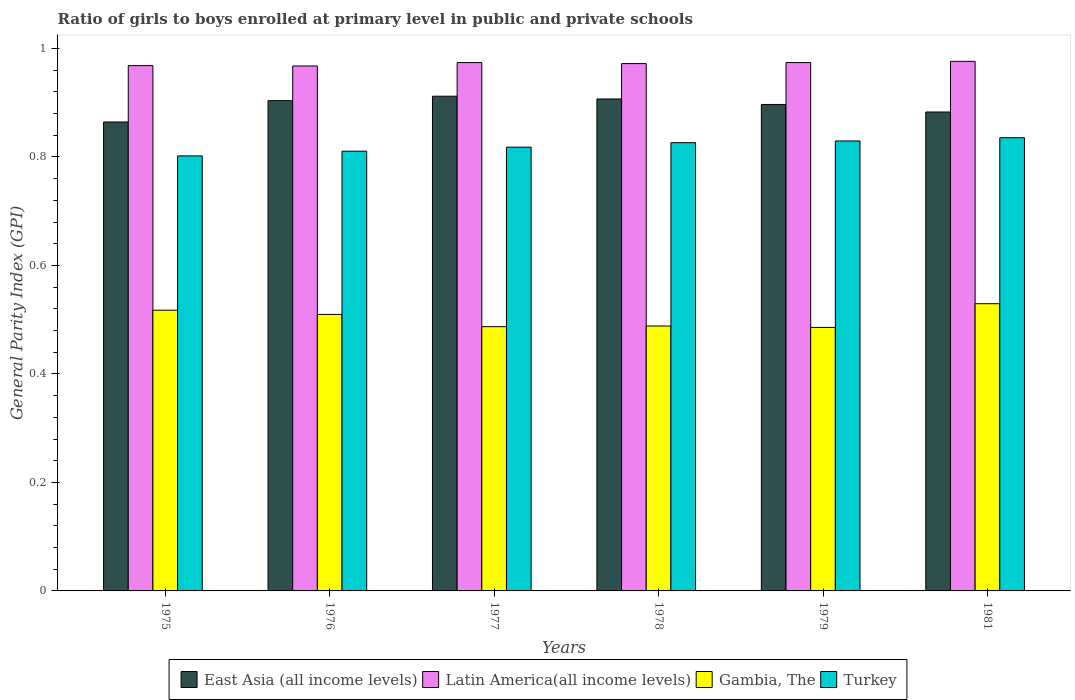Are the number of bars on each tick of the X-axis equal?
Provide a short and direct response. Yes. How many bars are there on the 1st tick from the left?
Keep it short and to the point. 4. How many bars are there on the 2nd tick from the right?
Your response must be concise. 4. What is the label of the 1st group of bars from the left?
Ensure brevity in your answer.  1975. What is the general parity index in Latin America(all income levels) in 1977?
Your answer should be compact. 0.97. Across all years, what is the maximum general parity index in Gambia, The?
Offer a terse response. 0.53. Across all years, what is the minimum general parity index in Turkey?
Keep it short and to the point. 0.8. In which year was the general parity index in Gambia, The maximum?
Offer a terse response. 1981. In which year was the general parity index in East Asia (all income levels) minimum?
Your response must be concise. 1975. What is the total general parity index in Latin America(all income levels) in the graph?
Make the answer very short. 5.83. What is the difference between the general parity index in Turkey in 1975 and that in 1978?
Keep it short and to the point. -0.02. What is the difference between the general parity index in Latin America(all income levels) in 1978 and the general parity index in Turkey in 1979?
Your response must be concise. 0.14. What is the average general parity index in Gambia, The per year?
Offer a very short reply. 0.5. In the year 1979, what is the difference between the general parity index in Turkey and general parity index in Gambia, The?
Offer a terse response. 0.34. What is the ratio of the general parity index in Gambia, The in 1978 to that in 1981?
Provide a short and direct response. 0.92. What is the difference between the highest and the second highest general parity index in Gambia, The?
Provide a succinct answer. 0.01. What is the difference between the highest and the lowest general parity index in Turkey?
Your answer should be compact. 0.03. What does the 2nd bar from the left in 1981 represents?
Give a very brief answer. Latin America(all income levels). What does the 2nd bar from the right in 1978 represents?
Keep it short and to the point. Gambia, The. How many bars are there?
Provide a succinct answer. 24. How many years are there in the graph?
Provide a short and direct response. 6. Does the graph contain grids?
Your answer should be very brief. No. How are the legend labels stacked?
Offer a very short reply. Horizontal. What is the title of the graph?
Make the answer very short. Ratio of girls to boys enrolled at primary level in public and private schools. What is the label or title of the X-axis?
Provide a short and direct response. Years. What is the label or title of the Y-axis?
Your answer should be compact. General Parity Index (GPI). What is the General Parity Index (GPI) of East Asia (all income levels) in 1975?
Make the answer very short. 0.86. What is the General Parity Index (GPI) of Latin America(all income levels) in 1975?
Your answer should be compact. 0.97. What is the General Parity Index (GPI) in Gambia, The in 1975?
Provide a succinct answer. 0.52. What is the General Parity Index (GPI) in Turkey in 1975?
Provide a succinct answer. 0.8. What is the General Parity Index (GPI) of East Asia (all income levels) in 1976?
Your answer should be compact. 0.9. What is the General Parity Index (GPI) of Latin America(all income levels) in 1976?
Provide a short and direct response. 0.97. What is the General Parity Index (GPI) in Gambia, The in 1976?
Your answer should be very brief. 0.51. What is the General Parity Index (GPI) in Turkey in 1976?
Your answer should be very brief. 0.81. What is the General Parity Index (GPI) in East Asia (all income levels) in 1977?
Your answer should be compact. 0.91. What is the General Parity Index (GPI) in Latin America(all income levels) in 1977?
Provide a succinct answer. 0.97. What is the General Parity Index (GPI) of Gambia, The in 1977?
Provide a succinct answer. 0.49. What is the General Parity Index (GPI) of Turkey in 1977?
Give a very brief answer. 0.82. What is the General Parity Index (GPI) of East Asia (all income levels) in 1978?
Provide a succinct answer. 0.91. What is the General Parity Index (GPI) of Latin America(all income levels) in 1978?
Your answer should be very brief. 0.97. What is the General Parity Index (GPI) in Gambia, The in 1978?
Offer a terse response. 0.49. What is the General Parity Index (GPI) of Turkey in 1978?
Offer a very short reply. 0.83. What is the General Parity Index (GPI) in East Asia (all income levels) in 1979?
Offer a very short reply. 0.9. What is the General Parity Index (GPI) of Latin America(all income levels) in 1979?
Your answer should be compact. 0.97. What is the General Parity Index (GPI) of Gambia, The in 1979?
Your answer should be compact. 0.49. What is the General Parity Index (GPI) in Turkey in 1979?
Make the answer very short. 0.83. What is the General Parity Index (GPI) in East Asia (all income levels) in 1981?
Keep it short and to the point. 0.88. What is the General Parity Index (GPI) in Latin America(all income levels) in 1981?
Your response must be concise. 0.98. What is the General Parity Index (GPI) in Gambia, The in 1981?
Give a very brief answer. 0.53. What is the General Parity Index (GPI) of Turkey in 1981?
Provide a succinct answer. 0.84. Across all years, what is the maximum General Parity Index (GPI) in East Asia (all income levels)?
Give a very brief answer. 0.91. Across all years, what is the maximum General Parity Index (GPI) of Latin America(all income levels)?
Your response must be concise. 0.98. Across all years, what is the maximum General Parity Index (GPI) in Gambia, The?
Your answer should be compact. 0.53. Across all years, what is the maximum General Parity Index (GPI) in Turkey?
Give a very brief answer. 0.84. Across all years, what is the minimum General Parity Index (GPI) of East Asia (all income levels)?
Ensure brevity in your answer.  0.86. Across all years, what is the minimum General Parity Index (GPI) of Latin America(all income levels)?
Provide a succinct answer. 0.97. Across all years, what is the minimum General Parity Index (GPI) in Gambia, The?
Ensure brevity in your answer.  0.49. Across all years, what is the minimum General Parity Index (GPI) of Turkey?
Give a very brief answer. 0.8. What is the total General Parity Index (GPI) in East Asia (all income levels) in the graph?
Ensure brevity in your answer.  5.37. What is the total General Parity Index (GPI) in Latin America(all income levels) in the graph?
Your answer should be compact. 5.83. What is the total General Parity Index (GPI) in Gambia, The in the graph?
Offer a very short reply. 3.02. What is the total General Parity Index (GPI) of Turkey in the graph?
Provide a succinct answer. 4.92. What is the difference between the General Parity Index (GPI) in East Asia (all income levels) in 1975 and that in 1976?
Give a very brief answer. -0.04. What is the difference between the General Parity Index (GPI) of Latin America(all income levels) in 1975 and that in 1976?
Give a very brief answer. 0. What is the difference between the General Parity Index (GPI) of Gambia, The in 1975 and that in 1976?
Ensure brevity in your answer.  0.01. What is the difference between the General Parity Index (GPI) of Turkey in 1975 and that in 1976?
Offer a terse response. -0.01. What is the difference between the General Parity Index (GPI) in East Asia (all income levels) in 1975 and that in 1977?
Make the answer very short. -0.05. What is the difference between the General Parity Index (GPI) of Latin America(all income levels) in 1975 and that in 1977?
Offer a very short reply. -0.01. What is the difference between the General Parity Index (GPI) in Gambia, The in 1975 and that in 1977?
Ensure brevity in your answer.  0.03. What is the difference between the General Parity Index (GPI) of Turkey in 1975 and that in 1977?
Your answer should be very brief. -0.02. What is the difference between the General Parity Index (GPI) of East Asia (all income levels) in 1975 and that in 1978?
Your response must be concise. -0.04. What is the difference between the General Parity Index (GPI) of Latin America(all income levels) in 1975 and that in 1978?
Make the answer very short. -0. What is the difference between the General Parity Index (GPI) in Gambia, The in 1975 and that in 1978?
Make the answer very short. 0.03. What is the difference between the General Parity Index (GPI) in Turkey in 1975 and that in 1978?
Make the answer very short. -0.02. What is the difference between the General Parity Index (GPI) in East Asia (all income levels) in 1975 and that in 1979?
Offer a terse response. -0.03. What is the difference between the General Parity Index (GPI) of Latin America(all income levels) in 1975 and that in 1979?
Give a very brief answer. -0.01. What is the difference between the General Parity Index (GPI) of Gambia, The in 1975 and that in 1979?
Give a very brief answer. 0.03. What is the difference between the General Parity Index (GPI) in Turkey in 1975 and that in 1979?
Your answer should be very brief. -0.03. What is the difference between the General Parity Index (GPI) of East Asia (all income levels) in 1975 and that in 1981?
Provide a short and direct response. -0.02. What is the difference between the General Parity Index (GPI) in Latin America(all income levels) in 1975 and that in 1981?
Ensure brevity in your answer.  -0.01. What is the difference between the General Parity Index (GPI) of Gambia, The in 1975 and that in 1981?
Your response must be concise. -0.01. What is the difference between the General Parity Index (GPI) in Turkey in 1975 and that in 1981?
Offer a terse response. -0.03. What is the difference between the General Parity Index (GPI) in East Asia (all income levels) in 1976 and that in 1977?
Offer a terse response. -0.01. What is the difference between the General Parity Index (GPI) in Latin America(all income levels) in 1976 and that in 1977?
Provide a short and direct response. -0.01. What is the difference between the General Parity Index (GPI) of Gambia, The in 1976 and that in 1977?
Give a very brief answer. 0.02. What is the difference between the General Parity Index (GPI) of Turkey in 1976 and that in 1977?
Offer a very short reply. -0.01. What is the difference between the General Parity Index (GPI) of East Asia (all income levels) in 1976 and that in 1978?
Your response must be concise. -0. What is the difference between the General Parity Index (GPI) of Latin America(all income levels) in 1976 and that in 1978?
Provide a succinct answer. -0. What is the difference between the General Parity Index (GPI) of Gambia, The in 1976 and that in 1978?
Provide a succinct answer. 0.02. What is the difference between the General Parity Index (GPI) in Turkey in 1976 and that in 1978?
Your answer should be compact. -0.02. What is the difference between the General Parity Index (GPI) in East Asia (all income levels) in 1976 and that in 1979?
Make the answer very short. 0.01. What is the difference between the General Parity Index (GPI) in Latin America(all income levels) in 1976 and that in 1979?
Your answer should be very brief. -0.01. What is the difference between the General Parity Index (GPI) in Gambia, The in 1976 and that in 1979?
Provide a short and direct response. 0.02. What is the difference between the General Parity Index (GPI) of Turkey in 1976 and that in 1979?
Keep it short and to the point. -0.02. What is the difference between the General Parity Index (GPI) of East Asia (all income levels) in 1976 and that in 1981?
Provide a succinct answer. 0.02. What is the difference between the General Parity Index (GPI) in Latin America(all income levels) in 1976 and that in 1981?
Your answer should be very brief. -0.01. What is the difference between the General Parity Index (GPI) in Gambia, The in 1976 and that in 1981?
Keep it short and to the point. -0.02. What is the difference between the General Parity Index (GPI) of Turkey in 1976 and that in 1981?
Ensure brevity in your answer.  -0.02. What is the difference between the General Parity Index (GPI) in East Asia (all income levels) in 1977 and that in 1978?
Provide a succinct answer. 0.01. What is the difference between the General Parity Index (GPI) in Latin America(all income levels) in 1977 and that in 1978?
Your response must be concise. 0. What is the difference between the General Parity Index (GPI) of Gambia, The in 1977 and that in 1978?
Give a very brief answer. -0. What is the difference between the General Parity Index (GPI) of Turkey in 1977 and that in 1978?
Offer a terse response. -0.01. What is the difference between the General Parity Index (GPI) of East Asia (all income levels) in 1977 and that in 1979?
Ensure brevity in your answer.  0.02. What is the difference between the General Parity Index (GPI) in Latin America(all income levels) in 1977 and that in 1979?
Your answer should be compact. 0. What is the difference between the General Parity Index (GPI) of Gambia, The in 1977 and that in 1979?
Your answer should be compact. 0. What is the difference between the General Parity Index (GPI) in Turkey in 1977 and that in 1979?
Your answer should be compact. -0.01. What is the difference between the General Parity Index (GPI) in East Asia (all income levels) in 1977 and that in 1981?
Give a very brief answer. 0.03. What is the difference between the General Parity Index (GPI) in Latin America(all income levels) in 1977 and that in 1981?
Offer a terse response. -0. What is the difference between the General Parity Index (GPI) of Gambia, The in 1977 and that in 1981?
Offer a very short reply. -0.04. What is the difference between the General Parity Index (GPI) in Turkey in 1977 and that in 1981?
Your answer should be compact. -0.02. What is the difference between the General Parity Index (GPI) in East Asia (all income levels) in 1978 and that in 1979?
Provide a succinct answer. 0.01. What is the difference between the General Parity Index (GPI) in Latin America(all income levels) in 1978 and that in 1979?
Give a very brief answer. -0. What is the difference between the General Parity Index (GPI) in Gambia, The in 1978 and that in 1979?
Your answer should be very brief. 0. What is the difference between the General Parity Index (GPI) of Turkey in 1978 and that in 1979?
Your response must be concise. -0. What is the difference between the General Parity Index (GPI) of East Asia (all income levels) in 1978 and that in 1981?
Keep it short and to the point. 0.02. What is the difference between the General Parity Index (GPI) of Latin America(all income levels) in 1978 and that in 1981?
Your answer should be compact. -0. What is the difference between the General Parity Index (GPI) in Gambia, The in 1978 and that in 1981?
Provide a short and direct response. -0.04. What is the difference between the General Parity Index (GPI) of Turkey in 1978 and that in 1981?
Give a very brief answer. -0.01. What is the difference between the General Parity Index (GPI) in East Asia (all income levels) in 1979 and that in 1981?
Your answer should be compact. 0.01. What is the difference between the General Parity Index (GPI) of Latin America(all income levels) in 1979 and that in 1981?
Provide a short and direct response. -0. What is the difference between the General Parity Index (GPI) of Gambia, The in 1979 and that in 1981?
Offer a terse response. -0.04. What is the difference between the General Parity Index (GPI) in Turkey in 1979 and that in 1981?
Provide a succinct answer. -0.01. What is the difference between the General Parity Index (GPI) of East Asia (all income levels) in 1975 and the General Parity Index (GPI) of Latin America(all income levels) in 1976?
Provide a short and direct response. -0.1. What is the difference between the General Parity Index (GPI) of East Asia (all income levels) in 1975 and the General Parity Index (GPI) of Gambia, The in 1976?
Ensure brevity in your answer.  0.35. What is the difference between the General Parity Index (GPI) of East Asia (all income levels) in 1975 and the General Parity Index (GPI) of Turkey in 1976?
Make the answer very short. 0.05. What is the difference between the General Parity Index (GPI) in Latin America(all income levels) in 1975 and the General Parity Index (GPI) in Gambia, The in 1976?
Make the answer very short. 0.46. What is the difference between the General Parity Index (GPI) in Latin America(all income levels) in 1975 and the General Parity Index (GPI) in Turkey in 1976?
Your response must be concise. 0.16. What is the difference between the General Parity Index (GPI) of Gambia, The in 1975 and the General Parity Index (GPI) of Turkey in 1976?
Ensure brevity in your answer.  -0.29. What is the difference between the General Parity Index (GPI) of East Asia (all income levels) in 1975 and the General Parity Index (GPI) of Latin America(all income levels) in 1977?
Your answer should be very brief. -0.11. What is the difference between the General Parity Index (GPI) of East Asia (all income levels) in 1975 and the General Parity Index (GPI) of Gambia, The in 1977?
Provide a succinct answer. 0.38. What is the difference between the General Parity Index (GPI) of East Asia (all income levels) in 1975 and the General Parity Index (GPI) of Turkey in 1977?
Make the answer very short. 0.05. What is the difference between the General Parity Index (GPI) in Latin America(all income levels) in 1975 and the General Parity Index (GPI) in Gambia, The in 1977?
Keep it short and to the point. 0.48. What is the difference between the General Parity Index (GPI) in Latin America(all income levels) in 1975 and the General Parity Index (GPI) in Turkey in 1977?
Your answer should be very brief. 0.15. What is the difference between the General Parity Index (GPI) of Gambia, The in 1975 and the General Parity Index (GPI) of Turkey in 1977?
Provide a short and direct response. -0.3. What is the difference between the General Parity Index (GPI) of East Asia (all income levels) in 1975 and the General Parity Index (GPI) of Latin America(all income levels) in 1978?
Your answer should be compact. -0.11. What is the difference between the General Parity Index (GPI) of East Asia (all income levels) in 1975 and the General Parity Index (GPI) of Gambia, The in 1978?
Provide a short and direct response. 0.38. What is the difference between the General Parity Index (GPI) in East Asia (all income levels) in 1975 and the General Parity Index (GPI) in Turkey in 1978?
Ensure brevity in your answer.  0.04. What is the difference between the General Parity Index (GPI) in Latin America(all income levels) in 1975 and the General Parity Index (GPI) in Gambia, The in 1978?
Your answer should be very brief. 0.48. What is the difference between the General Parity Index (GPI) of Latin America(all income levels) in 1975 and the General Parity Index (GPI) of Turkey in 1978?
Ensure brevity in your answer.  0.14. What is the difference between the General Parity Index (GPI) of Gambia, The in 1975 and the General Parity Index (GPI) of Turkey in 1978?
Your answer should be compact. -0.31. What is the difference between the General Parity Index (GPI) of East Asia (all income levels) in 1975 and the General Parity Index (GPI) of Latin America(all income levels) in 1979?
Provide a succinct answer. -0.11. What is the difference between the General Parity Index (GPI) of East Asia (all income levels) in 1975 and the General Parity Index (GPI) of Gambia, The in 1979?
Ensure brevity in your answer.  0.38. What is the difference between the General Parity Index (GPI) in East Asia (all income levels) in 1975 and the General Parity Index (GPI) in Turkey in 1979?
Keep it short and to the point. 0.04. What is the difference between the General Parity Index (GPI) in Latin America(all income levels) in 1975 and the General Parity Index (GPI) in Gambia, The in 1979?
Your answer should be compact. 0.48. What is the difference between the General Parity Index (GPI) of Latin America(all income levels) in 1975 and the General Parity Index (GPI) of Turkey in 1979?
Your answer should be compact. 0.14. What is the difference between the General Parity Index (GPI) of Gambia, The in 1975 and the General Parity Index (GPI) of Turkey in 1979?
Your answer should be very brief. -0.31. What is the difference between the General Parity Index (GPI) of East Asia (all income levels) in 1975 and the General Parity Index (GPI) of Latin America(all income levels) in 1981?
Make the answer very short. -0.11. What is the difference between the General Parity Index (GPI) of East Asia (all income levels) in 1975 and the General Parity Index (GPI) of Gambia, The in 1981?
Make the answer very short. 0.34. What is the difference between the General Parity Index (GPI) in East Asia (all income levels) in 1975 and the General Parity Index (GPI) in Turkey in 1981?
Your answer should be very brief. 0.03. What is the difference between the General Parity Index (GPI) in Latin America(all income levels) in 1975 and the General Parity Index (GPI) in Gambia, The in 1981?
Your response must be concise. 0.44. What is the difference between the General Parity Index (GPI) of Latin America(all income levels) in 1975 and the General Parity Index (GPI) of Turkey in 1981?
Your response must be concise. 0.13. What is the difference between the General Parity Index (GPI) in Gambia, The in 1975 and the General Parity Index (GPI) in Turkey in 1981?
Give a very brief answer. -0.32. What is the difference between the General Parity Index (GPI) of East Asia (all income levels) in 1976 and the General Parity Index (GPI) of Latin America(all income levels) in 1977?
Give a very brief answer. -0.07. What is the difference between the General Parity Index (GPI) in East Asia (all income levels) in 1976 and the General Parity Index (GPI) in Gambia, The in 1977?
Your answer should be compact. 0.42. What is the difference between the General Parity Index (GPI) in East Asia (all income levels) in 1976 and the General Parity Index (GPI) in Turkey in 1977?
Your answer should be very brief. 0.09. What is the difference between the General Parity Index (GPI) of Latin America(all income levels) in 1976 and the General Parity Index (GPI) of Gambia, The in 1977?
Make the answer very short. 0.48. What is the difference between the General Parity Index (GPI) of Latin America(all income levels) in 1976 and the General Parity Index (GPI) of Turkey in 1977?
Give a very brief answer. 0.15. What is the difference between the General Parity Index (GPI) of Gambia, The in 1976 and the General Parity Index (GPI) of Turkey in 1977?
Offer a terse response. -0.31. What is the difference between the General Parity Index (GPI) of East Asia (all income levels) in 1976 and the General Parity Index (GPI) of Latin America(all income levels) in 1978?
Provide a succinct answer. -0.07. What is the difference between the General Parity Index (GPI) in East Asia (all income levels) in 1976 and the General Parity Index (GPI) in Gambia, The in 1978?
Give a very brief answer. 0.42. What is the difference between the General Parity Index (GPI) in East Asia (all income levels) in 1976 and the General Parity Index (GPI) in Turkey in 1978?
Provide a succinct answer. 0.08. What is the difference between the General Parity Index (GPI) of Latin America(all income levels) in 1976 and the General Parity Index (GPI) of Gambia, The in 1978?
Offer a terse response. 0.48. What is the difference between the General Parity Index (GPI) of Latin America(all income levels) in 1976 and the General Parity Index (GPI) of Turkey in 1978?
Give a very brief answer. 0.14. What is the difference between the General Parity Index (GPI) of Gambia, The in 1976 and the General Parity Index (GPI) of Turkey in 1978?
Give a very brief answer. -0.32. What is the difference between the General Parity Index (GPI) of East Asia (all income levels) in 1976 and the General Parity Index (GPI) of Latin America(all income levels) in 1979?
Ensure brevity in your answer.  -0.07. What is the difference between the General Parity Index (GPI) of East Asia (all income levels) in 1976 and the General Parity Index (GPI) of Gambia, The in 1979?
Keep it short and to the point. 0.42. What is the difference between the General Parity Index (GPI) of East Asia (all income levels) in 1976 and the General Parity Index (GPI) of Turkey in 1979?
Ensure brevity in your answer.  0.07. What is the difference between the General Parity Index (GPI) of Latin America(all income levels) in 1976 and the General Parity Index (GPI) of Gambia, The in 1979?
Give a very brief answer. 0.48. What is the difference between the General Parity Index (GPI) in Latin America(all income levels) in 1976 and the General Parity Index (GPI) in Turkey in 1979?
Keep it short and to the point. 0.14. What is the difference between the General Parity Index (GPI) of Gambia, The in 1976 and the General Parity Index (GPI) of Turkey in 1979?
Ensure brevity in your answer.  -0.32. What is the difference between the General Parity Index (GPI) in East Asia (all income levels) in 1976 and the General Parity Index (GPI) in Latin America(all income levels) in 1981?
Ensure brevity in your answer.  -0.07. What is the difference between the General Parity Index (GPI) of East Asia (all income levels) in 1976 and the General Parity Index (GPI) of Gambia, The in 1981?
Provide a short and direct response. 0.37. What is the difference between the General Parity Index (GPI) in East Asia (all income levels) in 1976 and the General Parity Index (GPI) in Turkey in 1981?
Your response must be concise. 0.07. What is the difference between the General Parity Index (GPI) in Latin America(all income levels) in 1976 and the General Parity Index (GPI) in Gambia, The in 1981?
Provide a succinct answer. 0.44. What is the difference between the General Parity Index (GPI) in Latin America(all income levels) in 1976 and the General Parity Index (GPI) in Turkey in 1981?
Provide a short and direct response. 0.13. What is the difference between the General Parity Index (GPI) of Gambia, The in 1976 and the General Parity Index (GPI) of Turkey in 1981?
Your answer should be very brief. -0.33. What is the difference between the General Parity Index (GPI) in East Asia (all income levels) in 1977 and the General Parity Index (GPI) in Latin America(all income levels) in 1978?
Keep it short and to the point. -0.06. What is the difference between the General Parity Index (GPI) of East Asia (all income levels) in 1977 and the General Parity Index (GPI) of Gambia, The in 1978?
Your answer should be compact. 0.42. What is the difference between the General Parity Index (GPI) of East Asia (all income levels) in 1977 and the General Parity Index (GPI) of Turkey in 1978?
Ensure brevity in your answer.  0.09. What is the difference between the General Parity Index (GPI) of Latin America(all income levels) in 1977 and the General Parity Index (GPI) of Gambia, The in 1978?
Ensure brevity in your answer.  0.49. What is the difference between the General Parity Index (GPI) in Latin America(all income levels) in 1977 and the General Parity Index (GPI) in Turkey in 1978?
Provide a short and direct response. 0.15. What is the difference between the General Parity Index (GPI) of Gambia, The in 1977 and the General Parity Index (GPI) of Turkey in 1978?
Your answer should be compact. -0.34. What is the difference between the General Parity Index (GPI) of East Asia (all income levels) in 1977 and the General Parity Index (GPI) of Latin America(all income levels) in 1979?
Ensure brevity in your answer.  -0.06. What is the difference between the General Parity Index (GPI) of East Asia (all income levels) in 1977 and the General Parity Index (GPI) of Gambia, The in 1979?
Offer a very short reply. 0.43. What is the difference between the General Parity Index (GPI) of East Asia (all income levels) in 1977 and the General Parity Index (GPI) of Turkey in 1979?
Make the answer very short. 0.08. What is the difference between the General Parity Index (GPI) in Latin America(all income levels) in 1977 and the General Parity Index (GPI) in Gambia, The in 1979?
Keep it short and to the point. 0.49. What is the difference between the General Parity Index (GPI) of Latin America(all income levels) in 1977 and the General Parity Index (GPI) of Turkey in 1979?
Your answer should be very brief. 0.14. What is the difference between the General Parity Index (GPI) in Gambia, The in 1977 and the General Parity Index (GPI) in Turkey in 1979?
Your response must be concise. -0.34. What is the difference between the General Parity Index (GPI) of East Asia (all income levels) in 1977 and the General Parity Index (GPI) of Latin America(all income levels) in 1981?
Your answer should be compact. -0.06. What is the difference between the General Parity Index (GPI) in East Asia (all income levels) in 1977 and the General Parity Index (GPI) in Gambia, The in 1981?
Offer a very short reply. 0.38. What is the difference between the General Parity Index (GPI) of East Asia (all income levels) in 1977 and the General Parity Index (GPI) of Turkey in 1981?
Make the answer very short. 0.08. What is the difference between the General Parity Index (GPI) of Latin America(all income levels) in 1977 and the General Parity Index (GPI) of Gambia, The in 1981?
Your answer should be compact. 0.44. What is the difference between the General Parity Index (GPI) of Latin America(all income levels) in 1977 and the General Parity Index (GPI) of Turkey in 1981?
Keep it short and to the point. 0.14. What is the difference between the General Parity Index (GPI) in Gambia, The in 1977 and the General Parity Index (GPI) in Turkey in 1981?
Make the answer very short. -0.35. What is the difference between the General Parity Index (GPI) of East Asia (all income levels) in 1978 and the General Parity Index (GPI) of Latin America(all income levels) in 1979?
Give a very brief answer. -0.07. What is the difference between the General Parity Index (GPI) of East Asia (all income levels) in 1978 and the General Parity Index (GPI) of Gambia, The in 1979?
Provide a succinct answer. 0.42. What is the difference between the General Parity Index (GPI) of East Asia (all income levels) in 1978 and the General Parity Index (GPI) of Turkey in 1979?
Your answer should be compact. 0.08. What is the difference between the General Parity Index (GPI) of Latin America(all income levels) in 1978 and the General Parity Index (GPI) of Gambia, The in 1979?
Your answer should be compact. 0.49. What is the difference between the General Parity Index (GPI) of Latin America(all income levels) in 1978 and the General Parity Index (GPI) of Turkey in 1979?
Keep it short and to the point. 0.14. What is the difference between the General Parity Index (GPI) of Gambia, The in 1978 and the General Parity Index (GPI) of Turkey in 1979?
Provide a succinct answer. -0.34. What is the difference between the General Parity Index (GPI) in East Asia (all income levels) in 1978 and the General Parity Index (GPI) in Latin America(all income levels) in 1981?
Ensure brevity in your answer.  -0.07. What is the difference between the General Parity Index (GPI) of East Asia (all income levels) in 1978 and the General Parity Index (GPI) of Gambia, The in 1981?
Provide a succinct answer. 0.38. What is the difference between the General Parity Index (GPI) of East Asia (all income levels) in 1978 and the General Parity Index (GPI) of Turkey in 1981?
Offer a terse response. 0.07. What is the difference between the General Parity Index (GPI) in Latin America(all income levels) in 1978 and the General Parity Index (GPI) in Gambia, The in 1981?
Offer a terse response. 0.44. What is the difference between the General Parity Index (GPI) of Latin America(all income levels) in 1978 and the General Parity Index (GPI) of Turkey in 1981?
Provide a succinct answer. 0.14. What is the difference between the General Parity Index (GPI) of Gambia, The in 1978 and the General Parity Index (GPI) of Turkey in 1981?
Provide a short and direct response. -0.35. What is the difference between the General Parity Index (GPI) of East Asia (all income levels) in 1979 and the General Parity Index (GPI) of Latin America(all income levels) in 1981?
Your answer should be compact. -0.08. What is the difference between the General Parity Index (GPI) in East Asia (all income levels) in 1979 and the General Parity Index (GPI) in Gambia, The in 1981?
Make the answer very short. 0.37. What is the difference between the General Parity Index (GPI) in East Asia (all income levels) in 1979 and the General Parity Index (GPI) in Turkey in 1981?
Offer a very short reply. 0.06. What is the difference between the General Parity Index (GPI) of Latin America(all income levels) in 1979 and the General Parity Index (GPI) of Gambia, The in 1981?
Offer a terse response. 0.44. What is the difference between the General Parity Index (GPI) of Latin America(all income levels) in 1979 and the General Parity Index (GPI) of Turkey in 1981?
Your answer should be compact. 0.14. What is the difference between the General Parity Index (GPI) in Gambia, The in 1979 and the General Parity Index (GPI) in Turkey in 1981?
Make the answer very short. -0.35. What is the average General Parity Index (GPI) of East Asia (all income levels) per year?
Your response must be concise. 0.89. What is the average General Parity Index (GPI) in Gambia, The per year?
Keep it short and to the point. 0.5. What is the average General Parity Index (GPI) in Turkey per year?
Give a very brief answer. 0.82. In the year 1975, what is the difference between the General Parity Index (GPI) of East Asia (all income levels) and General Parity Index (GPI) of Latin America(all income levels)?
Keep it short and to the point. -0.1. In the year 1975, what is the difference between the General Parity Index (GPI) of East Asia (all income levels) and General Parity Index (GPI) of Gambia, The?
Make the answer very short. 0.35. In the year 1975, what is the difference between the General Parity Index (GPI) of East Asia (all income levels) and General Parity Index (GPI) of Turkey?
Offer a very short reply. 0.06. In the year 1975, what is the difference between the General Parity Index (GPI) of Latin America(all income levels) and General Parity Index (GPI) of Gambia, The?
Offer a terse response. 0.45. In the year 1975, what is the difference between the General Parity Index (GPI) in Latin America(all income levels) and General Parity Index (GPI) in Turkey?
Your answer should be compact. 0.17. In the year 1975, what is the difference between the General Parity Index (GPI) of Gambia, The and General Parity Index (GPI) of Turkey?
Offer a terse response. -0.28. In the year 1976, what is the difference between the General Parity Index (GPI) of East Asia (all income levels) and General Parity Index (GPI) of Latin America(all income levels)?
Keep it short and to the point. -0.06. In the year 1976, what is the difference between the General Parity Index (GPI) in East Asia (all income levels) and General Parity Index (GPI) in Gambia, The?
Make the answer very short. 0.39. In the year 1976, what is the difference between the General Parity Index (GPI) in East Asia (all income levels) and General Parity Index (GPI) in Turkey?
Your response must be concise. 0.09. In the year 1976, what is the difference between the General Parity Index (GPI) of Latin America(all income levels) and General Parity Index (GPI) of Gambia, The?
Offer a very short reply. 0.46. In the year 1976, what is the difference between the General Parity Index (GPI) in Latin America(all income levels) and General Parity Index (GPI) in Turkey?
Give a very brief answer. 0.16. In the year 1976, what is the difference between the General Parity Index (GPI) in Gambia, The and General Parity Index (GPI) in Turkey?
Your answer should be very brief. -0.3. In the year 1977, what is the difference between the General Parity Index (GPI) of East Asia (all income levels) and General Parity Index (GPI) of Latin America(all income levels)?
Your answer should be very brief. -0.06. In the year 1977, what is the difference between the General Parity Index (GPI) in East Asia (all income levels) and General Parity Index (GPI) in Gambia, The?
Provide a short and direct response. 0.42. In the year 1977, what is the difference between the General Parity Index (GPI) in East Asia (all income levels) and General Parity Index (GPI) in Turkey?
Offer a terse response. 0.09. In the year 1977, what is the difference between the General Parity Index (GPI) in Latin America(all income levels) and General Parity Index (GPI) in Gambia, The?
Offer a terse response. 0.49. In the year 1977, what is the difference between the General Parity Index (GPI) in Latin America(all income levels) and General Parity Index (GPI) in Turkey?
Make the answer very short. 0.16. In the year 1977, what is the difference between the General Parity Index (GPI) of Gambia, The and General Parity Index (GPI) of Turkey?
Your answer should be compact. -0.33. In the year 1978, what is the difference between the General Parity Index (GPI) in East Asia (all income levels) and General Parity Index (GPI) in Latin America(all income levels)?
Your answer should be very brief. -0.07. In the year 1978, what is the difference between the General Parity Index (GPI) in East Asia (all income levels) and General Parity Index (GPI) in Gambia, The?
Make the answer very short. 0.42. In the year 1978, what is the difference between the General Parity Index (GPI) in East Asia (all income levels) and General Parity Index (GPI) in Turkey?
Give a very brief answer. 0.08. In the year 1978, what is the difference between the General Parity Index (GPI) in Latin America(all income levels) and General Parity Index (GPI) in Gambia, The?
Keep it short and to the point. 0.48. In the year 1978, what is the difference between the General Parity Index (GPI) of Latin America(all income levels) and General Parity Index (GPI) of Turkey?
Your answer should be very brief. 0.15. In the year 1978, what is the difference between the General Parity Index (GPI) of Gambia, The and General Parity Index (GPI) of Turkey?
Provide a short and direct response. -0.34. In the year 1979, what is the difference between the General Parity Index (GPI) in East Asia (all income levels) and General Parity Index (GPI) in Latin America(all income levels)?
Keep it short and to the point. -0.08. In the year 1979, what is the difference between the General Parity Index (GPI) of East Asia (all income levels) and General Parity Index (GPI) of Gambia, The?
Give a very brief answer. 0.41. In the year 1979, what is the difference between the General Parity Index (GPI) of East Asia (all income levels) and General Parity Index (GPI) of Turkey?
Make the answer very short. 0.07. In the year 1979, what is the difference between the General Parity Index (GPI) of Latin America(all income levels) and General Parity Index (GPI) of Gambia, The?
Your response must be concise. 0.49. In the year 1979, what is the difference between the General Parity Index (GPI) in Latin America(all income levels) and General Parity Index (GPI) in Turkey?
Ensure brevity in your answer.  0.14. In the year 1979, what is the difference between the General Parity Index (GPI) in Gambia, The and General Parity Index (GPI) in Turkey?
Offer a very short reply. -0.34. In the year 1981, what is the difference between the General Parity Index (GPI) of East Asia (all income levels) and General Parity Index (GPI) of Latin America(all income levels)?
Offer a terse response. -0.09. In the year 1981, what is the difference between the General Parity Index (GPI) in East Asia (all income levels) and General Parity Index (GPI) in Gambia, The?
Ensure brevity in your answer.  0.35. In the year 1981, what is the difference between the General Parity Index (GPI) of East Asia (all income levels) and General Parity Index (GPI) of Turkey?
Make the answer very short. 0.05. In the year 1981, what is the difference between the General Parity Index (GPI) of Latin America(all income levels) and General Parity Index (GPI) of Gambia, The?
Offer a very short reply. 0.45. In the year 1981, what is the difference between the General Parity Index (GPI) of Latin America(all income levels) and General Parity Index (GPI) of Turkey?
Your answer should be very brief. 0.14. In the year 1981, what is the difference between the General Parity Index (GPI) in Gambia, The and General Parity Index (GPI) in Turkey?
Keep it short and to the point. -0.31. What is the ratio of the General Parity Index (GPI) in East Asia (all income levels) in 1975 to that in 1976?
Your answer should be very brief. 0.96. What is the ratio of the General Parity Index (GPI) of Latin America(all income levels) in 1975 to that in 1976?
Provide a succinct answer. 1. What is the ratio of the General Parity Index (GPI) in Gambia, The in 1975 to that in 1976?
Give a very brief answer. 1.02. What is the ratio of the General Parity Index (GPI) in Turkey in 1975 to that in 1976?
Your answer should be compact. 0.99. What is the ratio of the General Parity Index (GPI) in East Asia (all income levels) in 1975 to that in 1977?
Your answer should be very brief. 0.95. What is the ratio of the General Parity Index (GPI) of Gambia, The in 1975 to that in 1977?
Your response must be concise. 1.06. What is the ratio of the General Parity Index (GPI) of Turkey in 1975 to that in 1977?
Your response must be concise. 0.98. What is the ratio of the General Parity Index (GPI) in East Asia (all income levels) in 1975 to that in 1978?
Your answer should be very brief. 0.95. What is the ratio of the General Parity Index (GPI) of Latin America(all income levels) in 1975 to that in 1978?
Keep it short and to the point. 1. What is the ratio of the General Parity Index (GPI) in Gambia, The in 1975 to that in 1978?
Provide a succinct answer. 1.06. What is the ratio of the General Parity Index (GPI) of Turkey in 1975 to that in 1978?
Your answer should be very brief. 0.97. What is the ratio of the General Parity Index (GPI) of East Asia (all income levels) in 1975 to that in 1979?
Ensure brevity in your answer.  0.96. What is the ratio of the General Parity Index (GPI) in Latin America(all income levels) in 1975 to that in 1979?
Your answer should be compact. 0.99. What is the ratio of the General Parity Index (GPI) in Gambia, The in 1975 to that in 1979?
Provide a succinct answer. 1.07. What is the ratio of the General Parity Index (GPI) of Turkey in 1975 to that in 1979?
Your answer should be compact. 0.97. What is the ratio of the General Parity Index (GPI) of East Asia (all income levels) in 1975 to that in 1981?
Ensure brevity in your answer.  0.98. What is the ratio of the General Parity Index (GPI) of Gambia, The in 1975 to that in 1981?
Give a very brief answer. 0.98. What is the ratio of the General Parity Index (GPI) of Turkey in 1975 to that in 1981?
Your answer should be very brief. 0.96. What is the ratio of the General Parity Index (GPI) of Latin America(all income levels) in 1976 to that in 1977?
Offer a terse response. 0.99. What is the ratio of the General Parity Index (GPI) of Gambia, The in 1976 to that in 1977?
Give a very brief answer. 1.05. What is the ratio of the General Parity Index (GPI) in Turkey in 1976 to that in 1977?
Make the answer very short. 0.99. What is the ratio of the General Parity Index (GPI) in East Asia (all income levels) in 1976 to that in 1978?
Offer a very short reply. 1. What is the ratio of the General Parity Index (GPI) in Gambia, The in 1976 to that in 1978?
Your response must be concise. 1.04. What is the ratio of the General Parity Index (GPI) of Gambia, The in 1976 to that in 1979?
Make the answer very short. 1.05. What is the ratio of the General Parity Index (GPI) in Turkey in 1976 to that in 1979?
Your response must be concise. 0.98. What is the ratio of the General Parity Index (GPI) of East Asia (all income levels) in 1976 to that in 1981?
Your response must be concise. 1.02. What is the ratio of the General Parity Index (GPI) in Gambia, The in 1976 to that in 1981?
Make the answer very short. 0.96. What is the ratio of the General Parity Index (GPI) in Turkey in 1976 to that in 1981?
Offer a terse response. 0.97. What is the ratio of the General Parity Index (GPI) of East Asia (all income levels) in 1977 to that in 1978?
Make the answer very short. 1.01. What is the ratio of the General Parity Index (GPI) of Gambia, The in 1977 to that in 1979?
Your answer should be compact. 1. What is the ratio of the General Parity Index (GPI) of Turkey in 1977 to that in 1979?
Keep it short and to the point. 0.99. What is the ratio of the General Parity Index (GPI) of East Asia (all income levels) in 1977 to that in 1981?
Provide a short and direct response. 1.03. What is the ratio of the General Parity Index (GPI) in Latin America(all income levels) in 1977 to that in 1981?
Give a very brief answer. 1. What is the ratio of the General Parity Index (GPI) in Gambia, The in 1977 to that in 1981?
Ensure brevity in your answer.  0.92. What is the ratio of the General Parity Index (GPI) in Turkey in 1977 to that in 1981?
Offer a terse response. 0.98. What is the ratio of the General Parity Index (GPI) in East Asia (all income levels) in 1978 to that in 1979?
Provide a succinct answer. 1.01. What is the ratio of the General Parity Index (GPI) of Gambia, The in 1978 to that in 1979?
Your response must be concise. 1.01. What is the ratio of the General Parity Index (GPI) of Turkey in 1978 to that in 1979?
Make the answer very short. 1. What is the ratio of the General Parity Index (GPI) of East Asia (all income levels) in 1978 to that in 1981?
Your answer should be very brief. 1.03. What is the ratio of the General Parity Index (GPI) of Gambia, The in 1978 to that in 1981?
Keep it short and to the point. 0.92. What is the ratio of the General Parity Index (GPI) in Turkey in 1978 to that in 1981?
Your answer should be compact. 0.99. What is the ratio of the General Parity Index (GPI) in East Asia (all income levels) in 1979 to that in 1981?
Offer a very short reply. 1.02. What is the ratio of the General Parity Index (GPI) in Gambia, The in 1979 to that in 1981?
Provide a succinct answer. 0.92. What is the difference between the highest and the second highest General Parity Index (GPI) in East Asia (all income levels)?
Your answer should be very brief. 0.01. What is the difference between the highest and the second highest General Parity Index (GPI) in Latin America(all income levels)?
Provide a short and direct response. 0. What is the difference between the highest and the second highest General Parity Index (GPI) of Gambia, The?
Your answer should be very brief. 0.01. What is the difference between the highest and the second highest General Parity Index (GPI) of Turkey?
Your answer should be compact. 0.01. What is the difference between the highest and the lowest General Parity Index (GPI) of East Asia (all income levels)?
Offer a very short reply. 0.05. What is the difference between the highest and the lowest General Parity Index (GPI) in Latin America(all income levels)?
Your response must be concise. 0.01. What is the difference between the highest and the lowest General Parity Index (GPI) in Gambia, The?
Provide a succinct answer. 0.04. What is the difference between the highest and the lowest General Parity Index (GPI) of Turkey?
Provide a short and direct response. 0.03. 